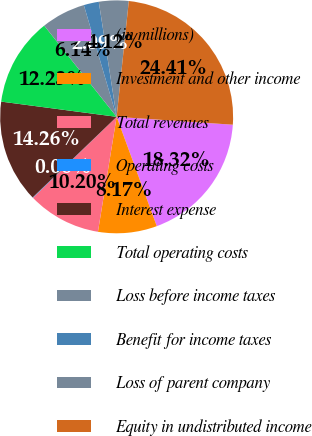Convert chart. <chart><loc_0><loc_0><loc_500><loc_500><pie_chart><fcel>(in millions)<fcel>Investment and other income<fcel>Total revenues<fcel>Operating costs<fcel>Interest expense<fcel>Total operating costs<fcel>Loss before income taxes<fcel>Benefit for income taxes<fcel>Loss of parent company<fcel>Equity in undistributed income<nl><fcel>18.32%<fcel>8.17%<fcel>10.2%<fcel>0.06%<fcel>14.26%<fcel>12.23%<fcel>6.14%<fcel>2.09%<fcel>4.12%<fcel>24.41%<nl></chart> 